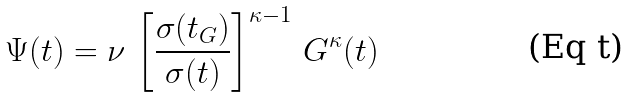Convert formula to latex. <formula><loc_0><loc_0><loc_500><loc_500>\Psi ( t ) = \nu \, \left [ \frac { \sigma ( t _ { G } ) } { \sigma ( t ) } \right ] ^ { \kappa - 1 } \, G ^ { \kappa } ( t )</formula> 